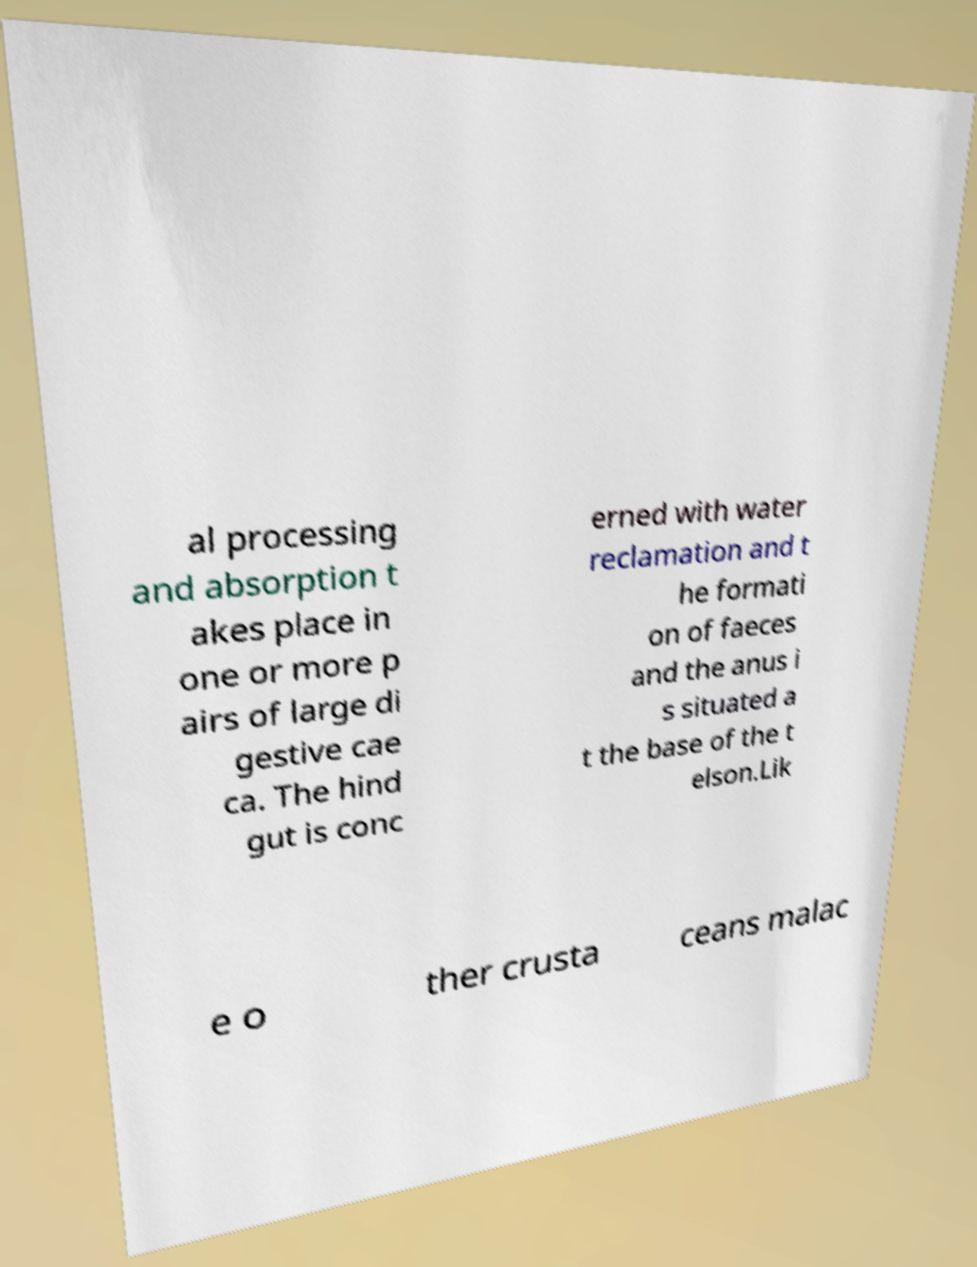For documentation purposes, I need the text within this image transcribed. Could you provide that? al processing and absorption t akes place in one or more p airs of large di gestive cae ca. The hind gut is conc erned with water reclamation and t he formati on of faeces and the anus i s situated a t the base of the t elson.Lik e o ther crusta ceans malac 